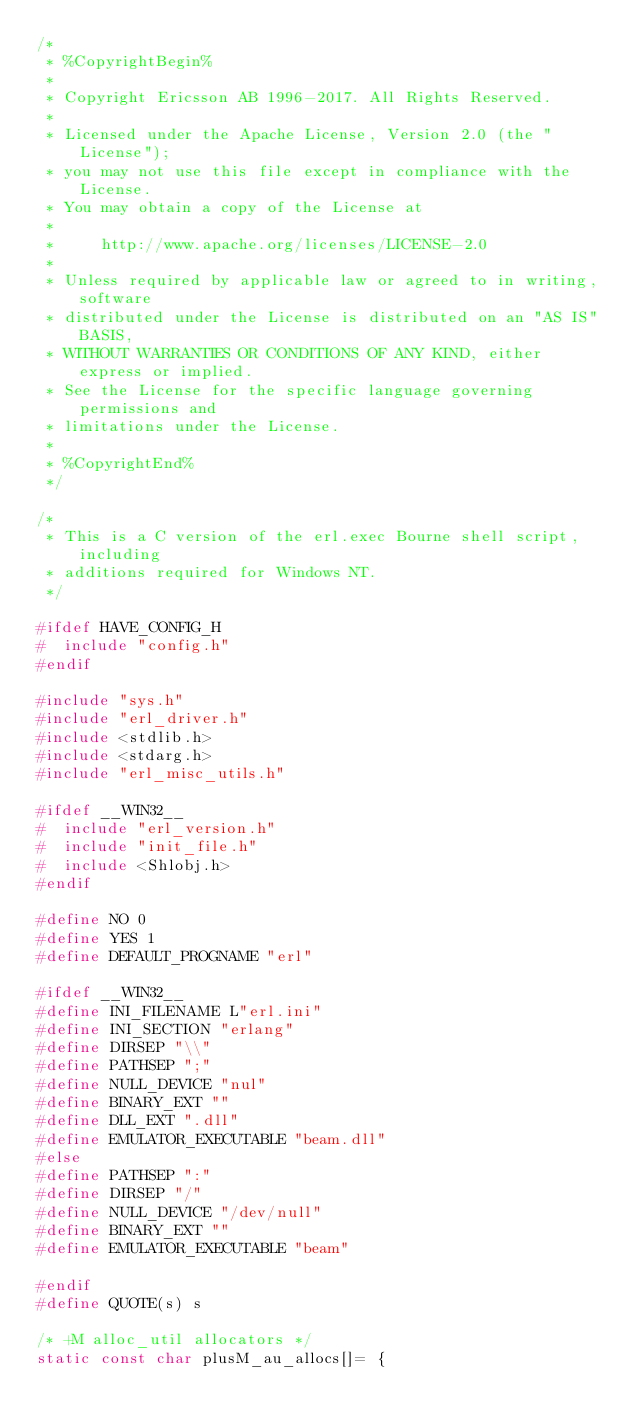<code> <loc_0><loc_0><loc_500><loc_500><_C_>/*
 * %CopyrightBegin%
 *
 * Copyright Ericsson AB 1996-2017. All Rights Reserved.
 *
 * Licensed under the Apache License, Version 2.0 (the "License");
 * you may not use this file except in compliance with the License.
 * You may obtain a copy of the License at
 *
 *     http://www.apache.org/licenses/LICENSE-2.0
 *
 * Unless required by applicable law or agreed to in writing, software
 * distributed under the License is distributed on an "AS IS" BASIS,
 * WITHOUT WARRANTIES OR CONDITIONS OF ANY KIND, either express or implied.
 * See the License for the specific language governing permissions and
 * limitations under the License.
 *
 * %CopyrightEnd%
 */

/*
 * This is a C version of the erl.exec Bourne shell script, including
 * additions required for Windows NT.
 */

#ifdef HAVE_CONFIG_H
#  include "config.h"
#endif

#include "sys.h"
#include "erl_driver.h"
#include <stdlib.h>
#include <stdarg.h>
#include "erl_misc_utils.h"

#ifdef __WIN32__
#  include "erl_version.h"
#  include "init_file.h"
#  include <Shlobj.h>
#endif

#define NO 0
#define YES 1
#define DEFAULT_PROGNAME "erl"

#ifdef __WIN32__
#define INI_FILENAME L"erl.ini"
#define INI_SECTION "erlang"
#define DIRSEP "\\"
#define PATHSEP ";"
#define NULL_DEVICE "nul"
#define BINARY_EXT ""
#define DLL_EXT ".dll"
#define EMULATOR_EXECUTABLE "beam.dll"
#else
#define PATHSEP ":"
#define DIRSEP "/"
#define NULL_DEVICE "/dev/null"
#define BINARY_EXT ""
#define EMULATOR_EXECUTABLE "beam"

#endif
#define QUOTE(s) s

/* +M alloc_util allocators */
static const char plusM_au_allocs[]= {</code> 